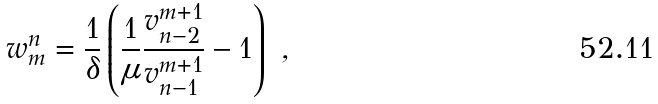Convert formula to latex. <formula><loc_0><loc_0><loc_500><loc_500>w _ { m } ^ { n } = \frac { 1 } { \delta } \left ( \frac { 1 } { \mu } \frac { v _ { n - 2 } ^ { m + 1 } } { v _ { n - 1 } ^ { m + 1 } } - 1 \right ) \ ,</formula> 